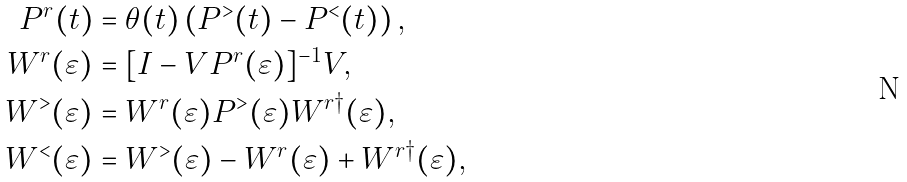Convert formula to latex. <formula><loc_0><loc_0><loc_500><loc_500>P ^ { r } ( t ) & = \theta ( t ) \left ( P ^ { > } ( t ) - P ^ { < } ( t ) \right ) , \\ W ^ { r } ( \varepsilon ) & = [ I - V P ^ { r } ( \varepsilon ) ] ^ { - 1 } V , \\ W ^ { > } ( \varepsilon ) & = W ^ { r } ( \varepsilon ) P ^ { > } ( \varepsilon ) W ^ { r \dagger } ( \varepsilon ) , \\ W ^ { < } ( \varepsilon ) & = W ^ { > } ( \varepsilon ) - W ^ { r } ( \varepsilon ) + W ^ { r \dagger } ( \varepsilon ) ,</formula> 